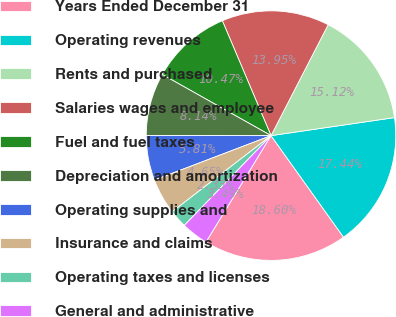Convert chart to OTSL. <chart><loc_0><loc_0><loc_500><loc_500><pie_chart><fcel>Years Ended December 31<fcel>Operating revenues<fcel>Rents and purchased<fcel>Salaries wages and employee<fcel>Fuel and fuel taxes<fcel>Depreciation and amortization<fcel>Operating supplies and<fcel>Insurance and claims<fcel>Operating taxes and licenses<fcel>General and administrative<nl><fcel>18.6%<fcel>17.44%<fcel>15.12%<fcel>13.95%<fcel>10.47%<fcel>8.14%<fcel>5.81%<fcel>4.65%<fcel>2.33%<fcel>3.49%<nl></chart> 